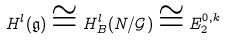<formula> <loc_0><loc_0><loc_500><loc_500>H ^ { l } ( \mathfrak { g } ) \cong H _ { B } ^ { l } ( N / \mathcal { G } ) \cong E _ { 2 } ^ { 0 , k }</formula> 